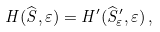Convert formula to latex. <formula><loc_0><loc_0><loc_500><loc_500>H ( \widehat { S } , \varepsilon ) = H ^ { \prime } ( \widehat { S } ^ { \prime } _ { \varepsilon } , \varepsilon ) \, ,</formula> 